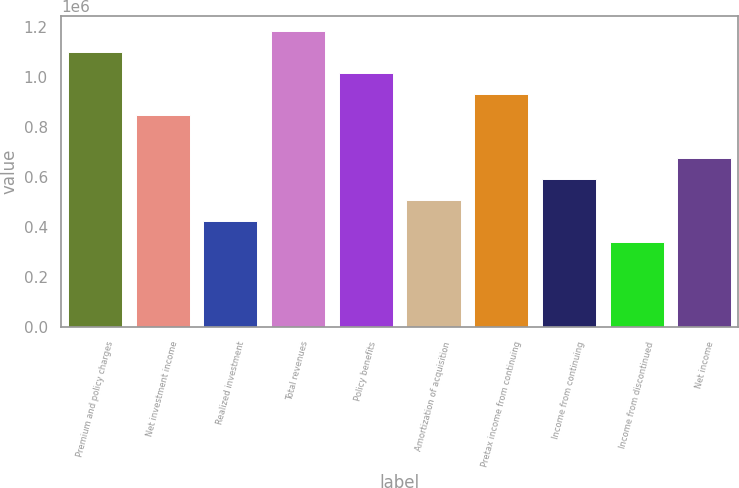<chart> <loc_0><loc_0><loc_500><loc_500><bar_chart><fcel>Premium and policy charges<fcel>Net investment income<fcel>Realized investment<fcel>Total revenues<fcel>Policy benefits<fcel>Amortization of acquisition<fcel>Pretax income from continuing<fcel>Income from continuing<fcel>Income from discontinued<fcel>Net income<nl><fcel>1.10132e+06<fcel>847171<fcel>423586<fcel>1.18604e+06<fcel>1.01661e+06<fcel>508303<fcel>931888<fcel>593020<fcel>338868<fcel>677737<nl></chart> 